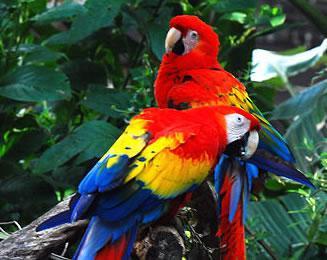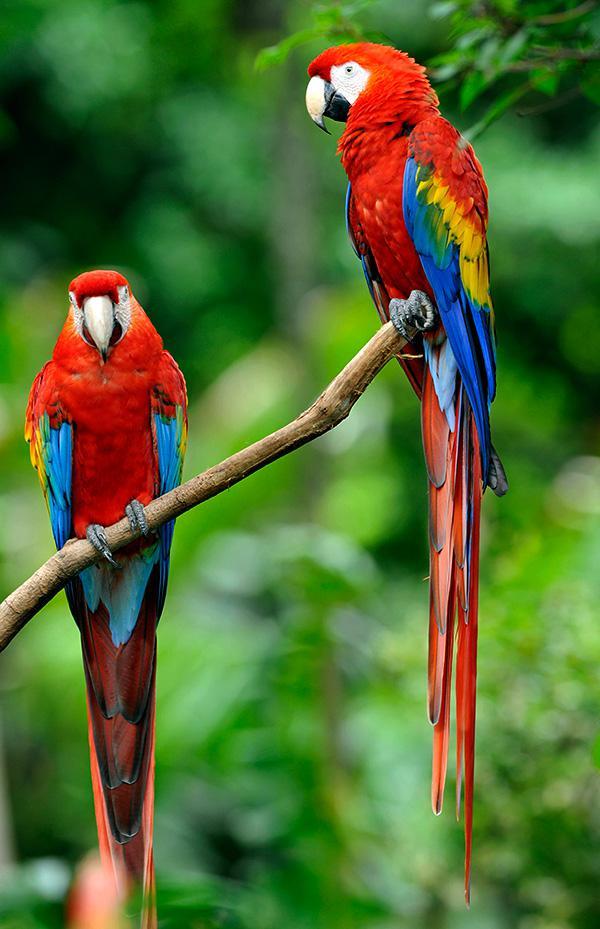The first image is the image on the left, the second image is the image on the right. Examine the images to the left and right. Is the description "Three parrots have red feathered heads and white beaks." accurate? Answer yes or no. No. 